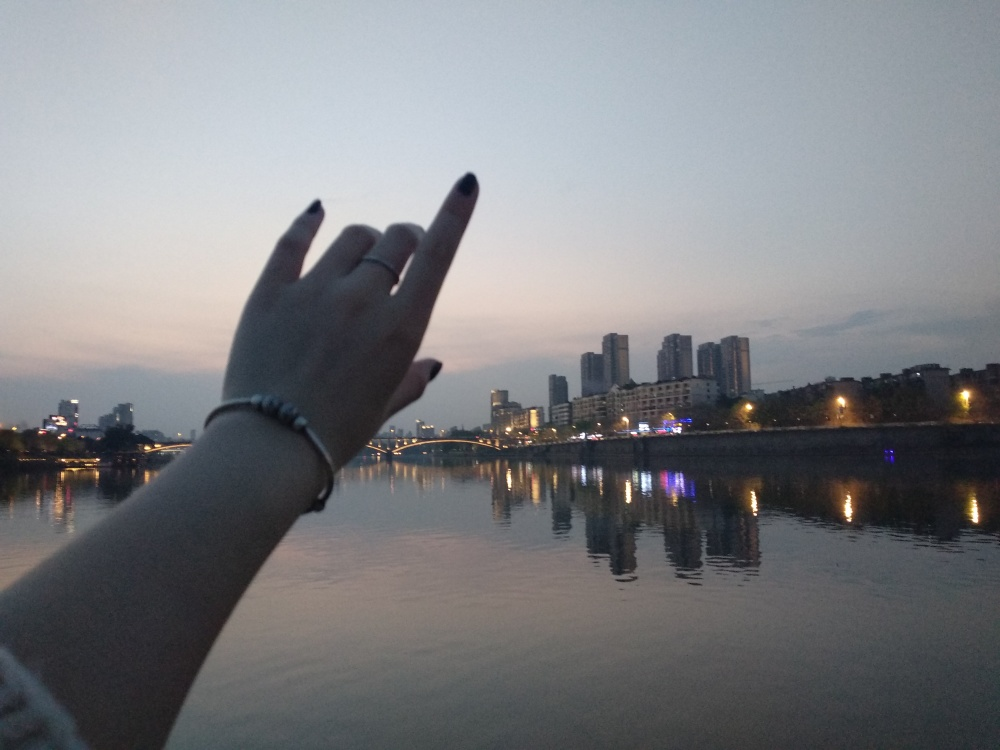What reflections are visible in the river, and what do they add to the image? The river reflects the city lights, showing glimmers of yellow and white, with occasional flares of color from the neon signs or traffic. These reflections add depth and a sense of life to the image. They create a connection between the city and the river, suggesting a harmony between the natural and man-made elements in the scene. 